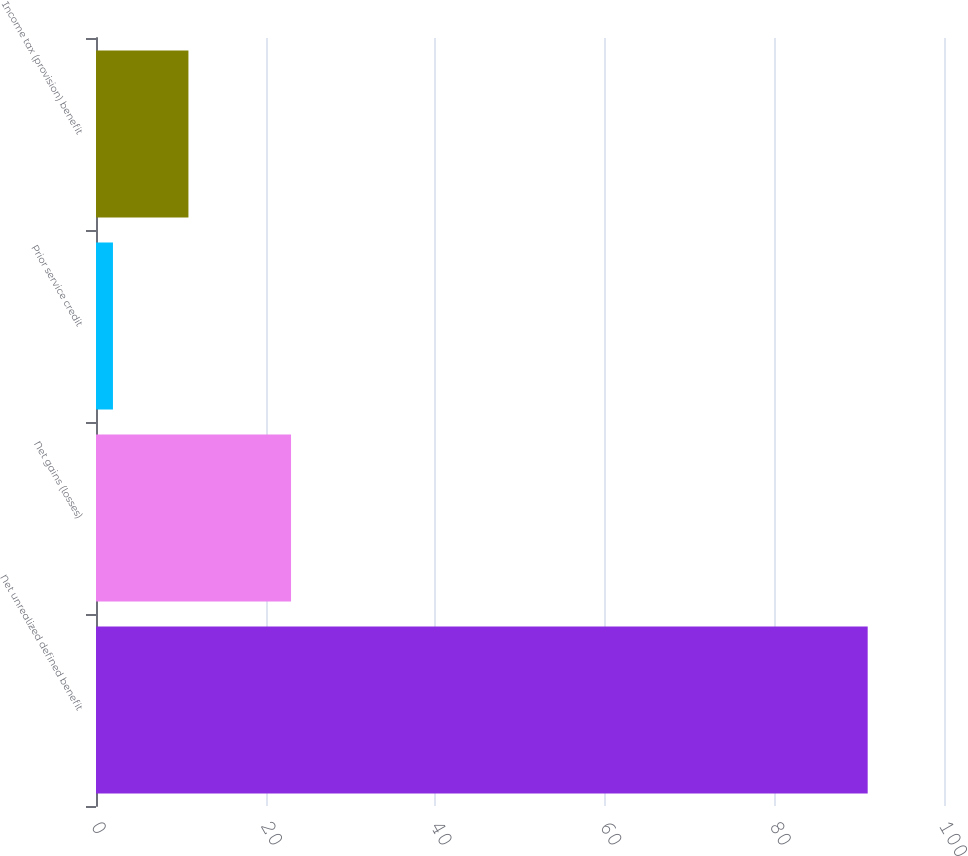<chart> <loc_0><loc_0><loc_500><loc_500><bar_chart><fcel>Net unrealized defined benefit<fcel>Net gains (losses)<fcel>Prior service credit<fcel>Income tax (provision) benefit<nl><fcel>91<fcel>23<fcel>2<fcel>10.9<nl></chart> 